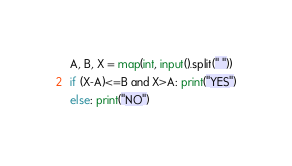Convert code to text. <code><loc_0><loc_0><loc_500><loc_500><_Python_>A, B, X = map(int, input().split(" "))
if (X-A)<=B and X>A: print("YES")
else: print("NO")
</code> 